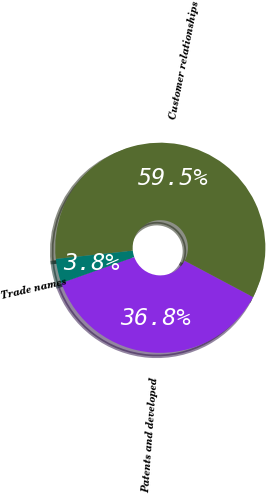Convert chart to OTSL. <chart><loc_0><loc_0><loc_500><loc_500><pie_chart><fcel>Patents and developed<fcel>Customer relationships<fcel>Trade names<nl><fcel>36.78%<fcel>59.47%<fcel>3.75%<nl></chart> 